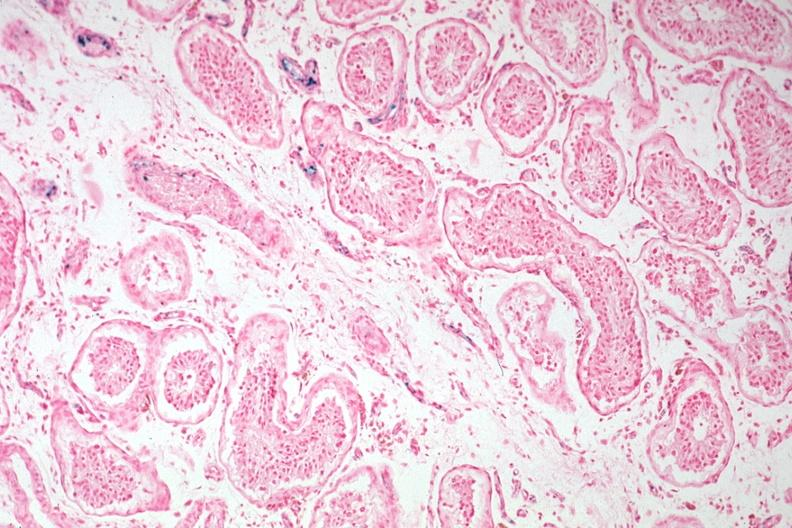what is present?
Answer the question using a single word or phrase. Testicle 